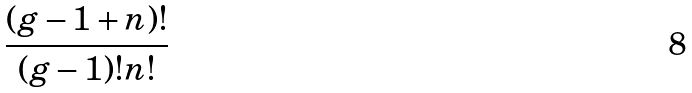Convert formula to latex. <formula><loc_0><loc_0><loc_500><loc_500>\frac { ( g - 1 + n ) ! } { ( g - 1 ) ! n ! }</formula> 